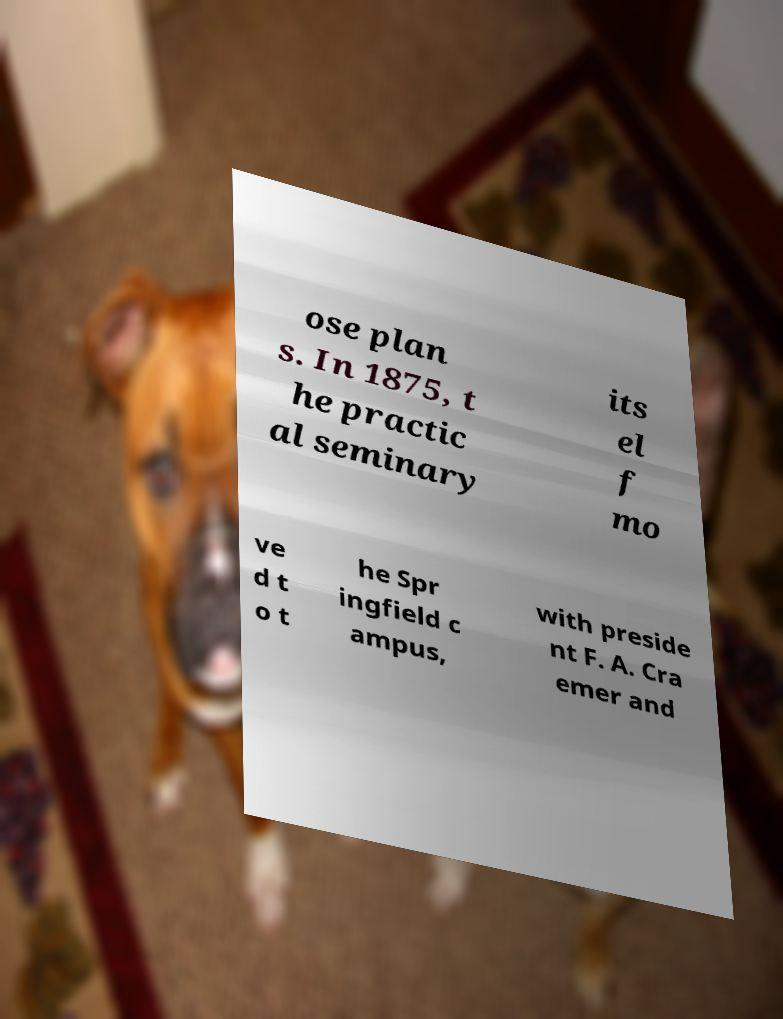Could you extract and type out the text from this image? ose plan s. In 1875, t he practic al seminary its el f mo ve d t o t he Spr ingfield c ampus, with preside nt F. A. Cra emer and 